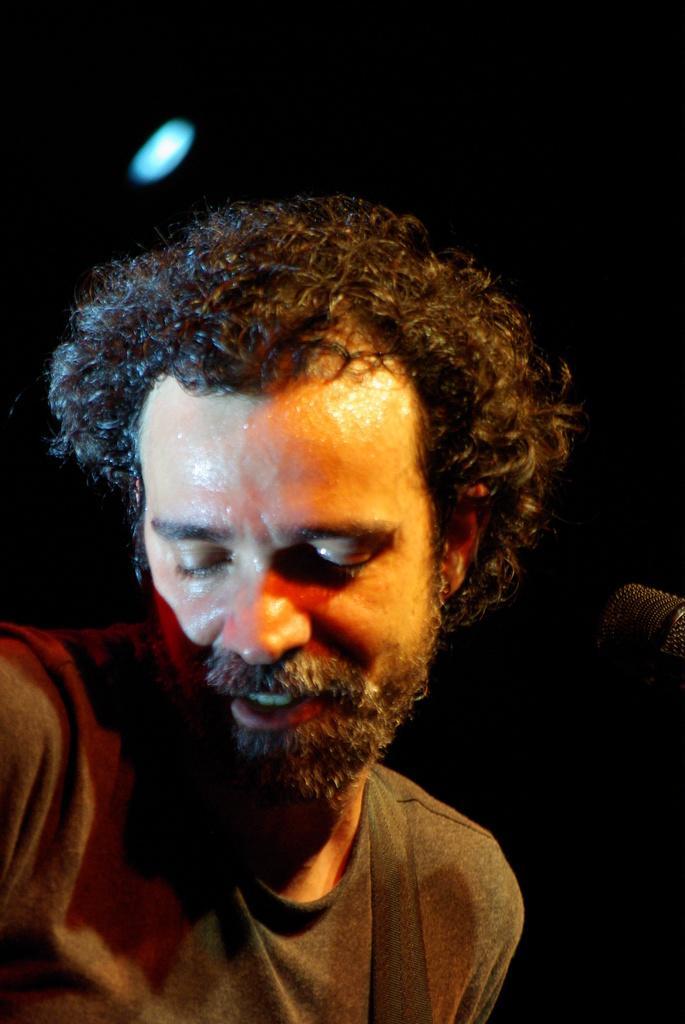Describe this image in one or two sentences. In the picture I can see a man and some other thing. The background of the image is dark. 